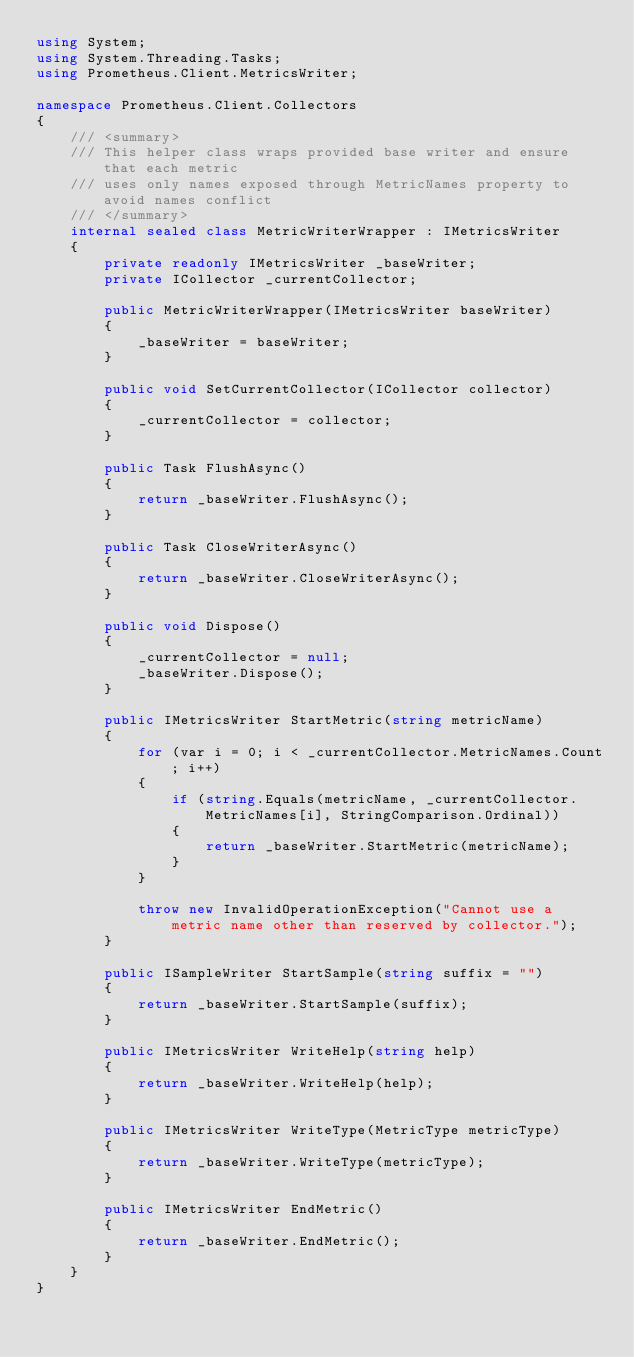<code> <loc_0><loc_0><loc_500><loc_500><_C#_>using System;
using System.Threading.Tasks;
using Prometheus.Client.MetricsWriter;

namespace Prometheus.Client.Collectors
{
    /// <summary>
    /// This helper class wraps provided base writer and ensure that each metric
    /// uses only names exposed through MetricNames property to avoid names conflict
    /// </summary>
    internal sealed class MetricWriterWrapper : IMetricsWriter
    {
        private readonly IMetricsWriter _baseWriter;
        private ICollector _currentCollector;

        public MetricWriterWrapper(IMetricsWriter baseWriter)
        {
            _baseWriter = baseWriter;
        }

        public void SetCurrentCollector(ICollector collector)
        {
            _currentCollector = collector;
        }

        public Task FlushAsync()
        {
            return _baseWriter.FlushAsync();
        }

        public Task CloseWriterAsync()
        {
            return _baseWriter.CloseWriterAsync();
        }

        public void Dispose()
        {
            _currentCollector = null;
            _baseWriter.Dispose();
        }

        public IMetricsWriter StartMetric(string metricName)
        {
            for (var i = 0; i < _currentCollector.MetricNames.Count; i++)
            {
                if (string.Equals(metricName, _currentCollector.MetricNames[i], StringComparison.Ordinal))
                {
                    return _baseWriter.StartMetric(metricName);
                }
            }

            throw new InvalidOperationException("Cannot use a metric name other than reserved by collector.");
        }

        public ISampleWriter StartSample(string suffix = "")
        {
            return _baseWriter.StartSample(suffix);
        }

        public IMetricsWriter WriteHelp(string help)
        {
            return _baseWriter.WriteHelp(help);
        }

        public IMetricsWriter WriteType(MetricType metricType)
        {
            return _baseWriter.WriteType(metricType);
        }

        public IMetricsWriter EndMetric()
        {
            return _baseWriter.EndMetric();
        }
    }
}
</code> 